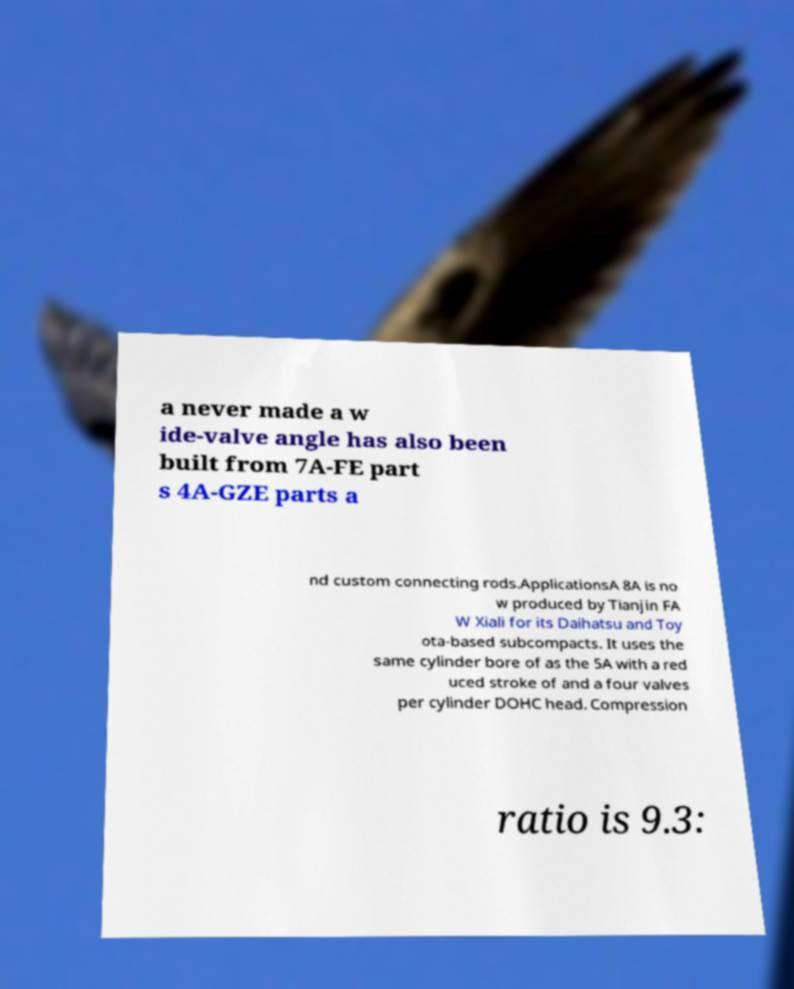Could you extract and type out the text from this image? a never made a w ide-valve angle has also been built from 7A-FE part s 4A-GZE parts a nd custom connecting rods.ApplicationsA 8A is no w produced by Tianjin FA W Xiali for its Daihatsu and Toy ota-based subcompacts. It uses the same cylinder bore of as the 5A with a red uced stroke of and a four valves per cylinder DOHC head. Compression ratio is 9.3: 